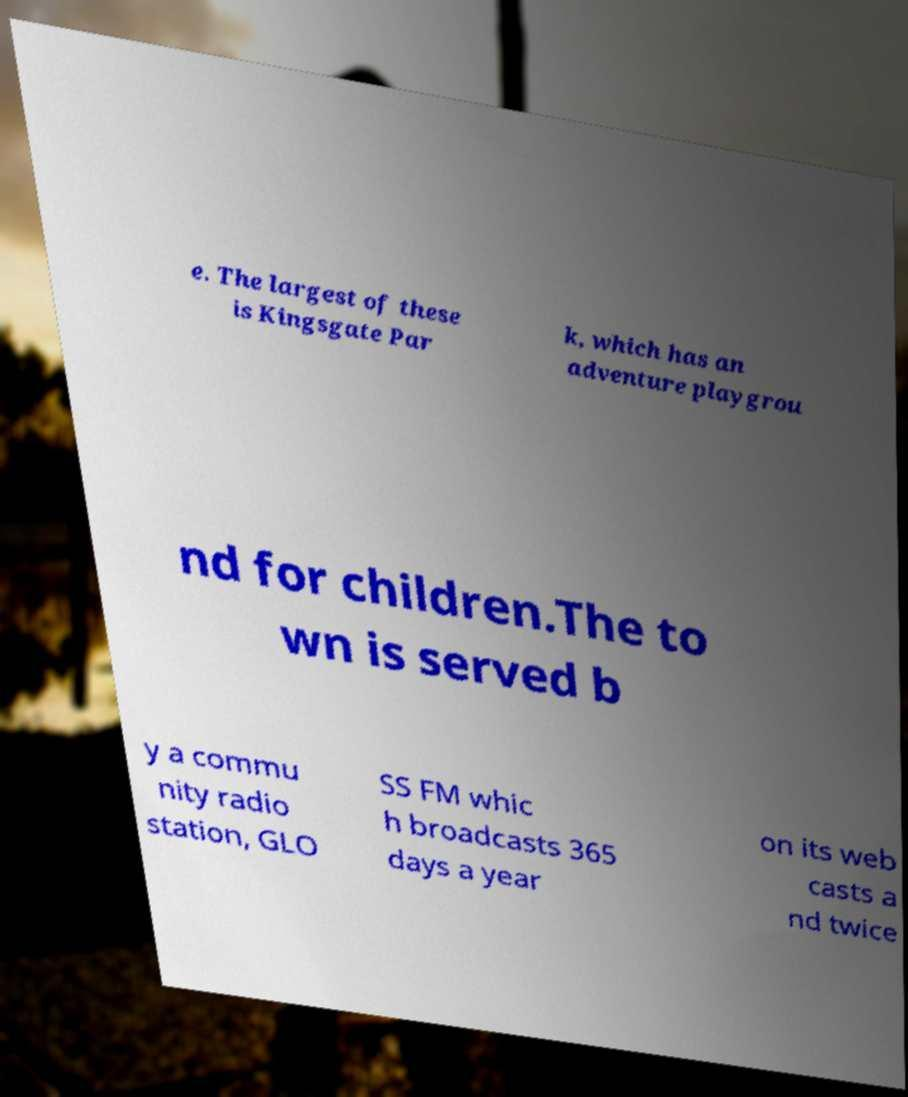Can you read and provide the text displayed in the image?This photo seems to have some interesting text. Can you extract and type it out for me? e. The largest of these is Kingsgate Par k, which has an adventure playgrou nd for children.The to wn is served b y a commu nity radio station, GLO SS FM whic h broadcasts 365 days a year on its web casts a nd twice 